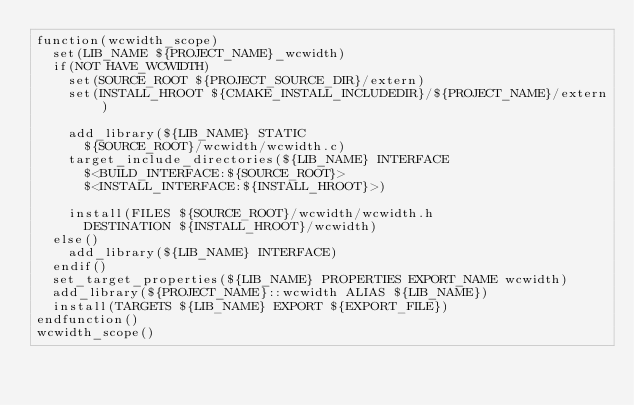<code> <loc_0><loc_0><loc_500><loc_500><_CMake_>function(wcwidth_scope)
	set(LIB_NAME ${PROJECT_NAME}_wcwidth)
	if(NOT HAVE_WCWIDTH)
		set(SOURCE_ROOT ${PROJECT_SOURCE_DIR}/extern)
		set(INSTALL_HROOT ${CMAKE_INSTALL_INCLUDEDIR}/${PROJECT_NAME}/extern)

		add_library(${LIB_NAME} STATIC
			${SOURCE_ROOT}/wcwidth/wcwidth.c)
		target_include_directories(${LIB_NAME} INTERFACE 
			$<BUILD_INTERFACE:${SOURCE_ROOT}>
			$<INSTALL_INTERFACE:${INSTALL_HROOT}>)

		install(FILES ${SOURCE_ROOT}/wcwidth/wcwidth.h
			DESTINATION ${INSTALL_HROOT}/wcwidth)
	else()
		add_library(${LIB_NAME} INTERFACE)
	endif()
	set_target_properties(${LIB_NAME} PROPERTIES EXPORT_NAME wcwidth)
	add_library(${PROJECT_NAME}::wcwidth ALIAS ${LIB_NAME})
	install(TARGETS ${LIB_NAME} EXPORT ${EXPORT_FILE})
endfunction()
wcwidth_scope()
</code> 